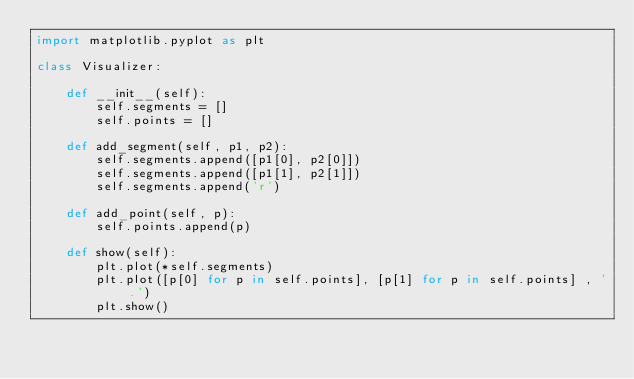<code> <loc_0><loc_0><loc_500><loc_500><_Python_>import matplotlib.pyplot as plt

class Visualizer:

    def __init__(self):
        self.segments = []
        self.points = []

    def add_segment(self, p1, p2):
        self.segments.append([p1[0], p2[0]])
        self.segments.append([p1[1], p2[1]])
        self.segments.append('r')

    def add_point(self, p):
        self.points.append(p)

    def show(self):
        plt.plot(*self.segments)
        plt.plot([p[0] for p in self.points], [p[1] for p in self.points] , '.')
        plt.show()

</code> 